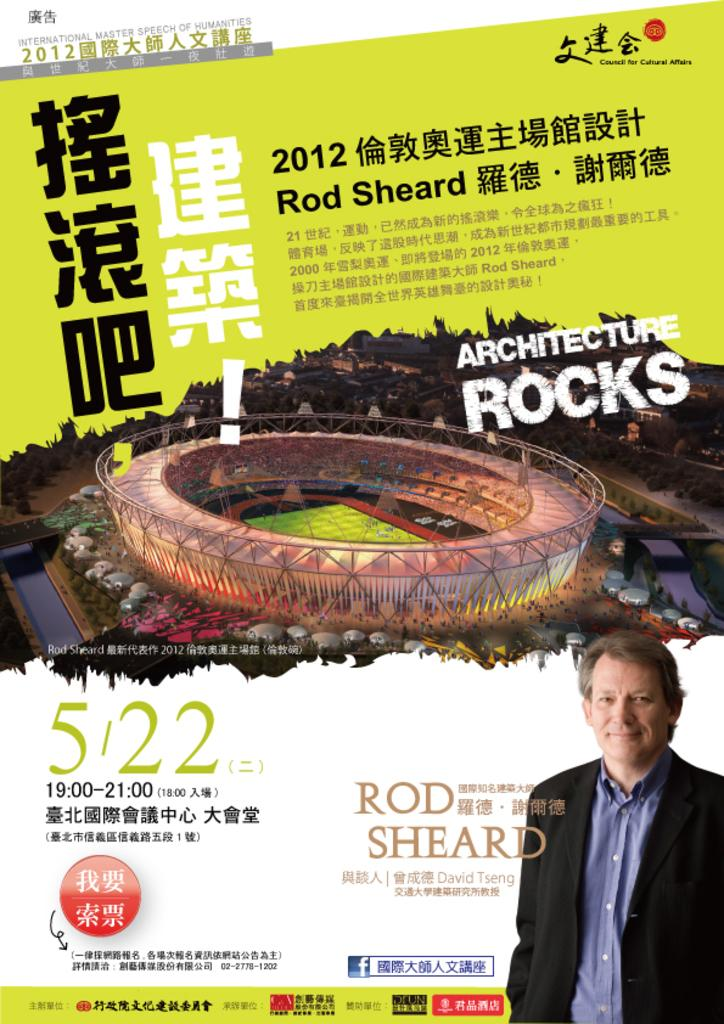What is present on the poster in the image? There is a poster in the image. What can be seen on the poster? The poster contains two images and texts in different languages. Are there any numerical elements on the poster? Yes, there are numbers on the poster. What is the color of the background on the poster? The background of the poster is white in color. What type of locket can be seen hanging from the poster in the image? There is no locket present on the poster in the image. How many eggs are visible in the image? There are no eggs visible in the image. 